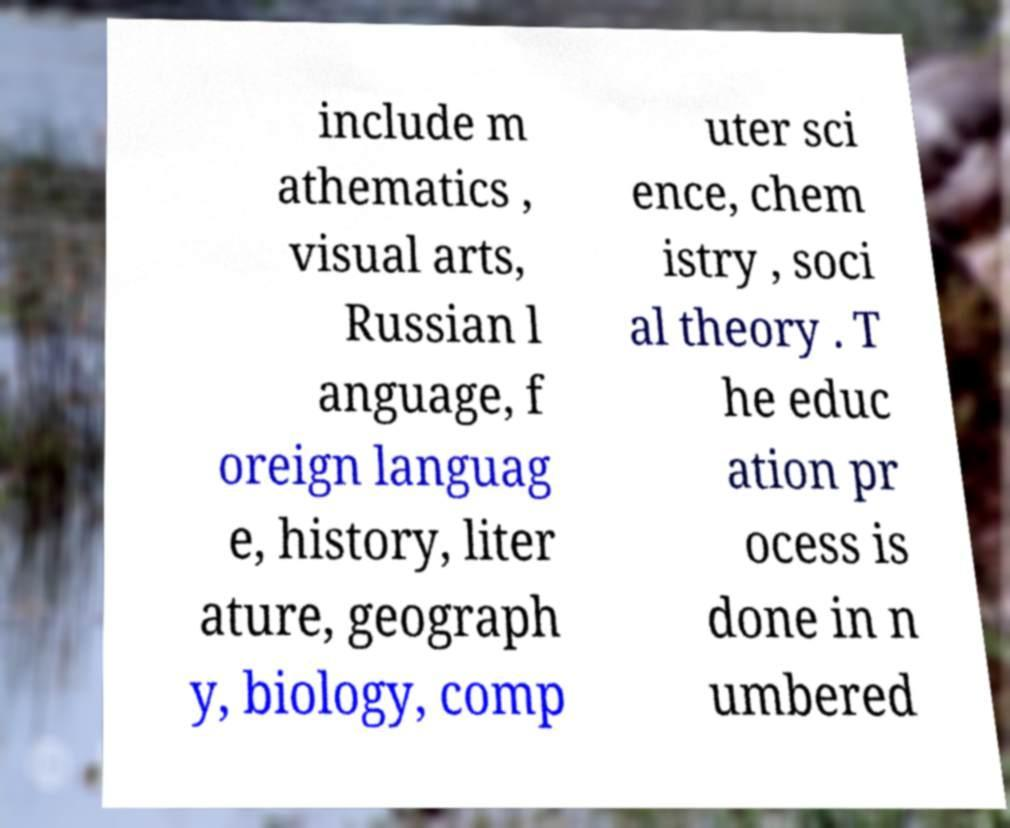For documentation purposes, I need the text within this image transcribed. Could you provide that? include m athematics , visual arts, Russian l anguage, f oreign languag e, history, liter ature, geograph y, biology, comp uter sci ence, chem istry , soci al theory . T he educ ation pr ocess is done in n umbered 